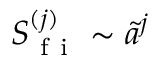<formula> <loc_0><loc_0><loc_500><loc_500>S _ { f i } ^ { ( j ) } \sim \tilde { a } ^ { j }</formula> 